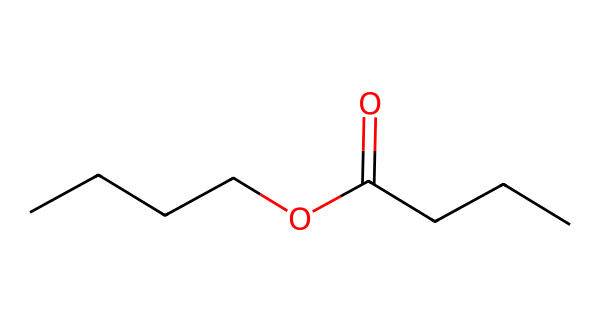What is the molecular formula of butyl butyrate? To get the molecular formula, count the carbon (C), hydrogen (H), and oxygen (O) atoms in the structure. The chemical has 8 carbons, 16 hydrogens, and 2 oxygens, leading to the formula C8H16O2.
Answer: C8H16O2 How many carbon atoms are in butyl butyrate? By examining the structure, you can see that there are a total of 8 carbon atoms present in the molecule.
Answer: 8 What functional groups are present in butyl butyrate? The structure contains an ester functional group, which is characterized by the carbonyl (C=O) and the ether link (C-O), allowing which leads to its classification as an ester.
Answer: ester How many hydrogen atoms are attached to the terminal carbon in the butyl group? The butyl group (CCCC) has a terminal carbon that is bound to three hydrogen atoms and one carbon atom. Therefore, it has 3 hydrogen atoms.
Answer: 3 What type of reaction forms butyl butyrate? Butyl butyrate is formed through an esterification reaction, specifically the reaction between an alcohol and a carboxylic acid resulting in the formation of an ester and water.
Answer: esterification Which part of the chemical structure gives butyl butyrate its fruity aroma? The ester functional group is responsible for the characteristic fruity aroma, as esters are well-known for imparting pleasant smells reminiscent of fruits.
Answer: ester functional group 